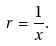<formula> <loc_0><loc_0><loc_500><loc_500>r = \frac { 1 } { x } .</formula> 